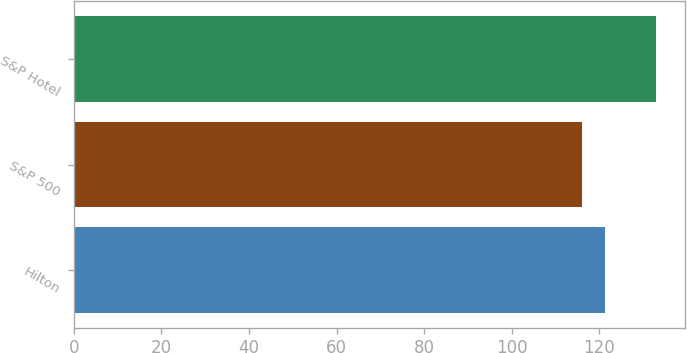<chart> <loc_0><loc_0><loc_500><loc_500><bar_chart><fcel>Hilton<fcel>S&P 500<fcel>S&P Hotel<nl><fcel>121.35<fcel>115.96<fcel>132.84<nl></chart> 